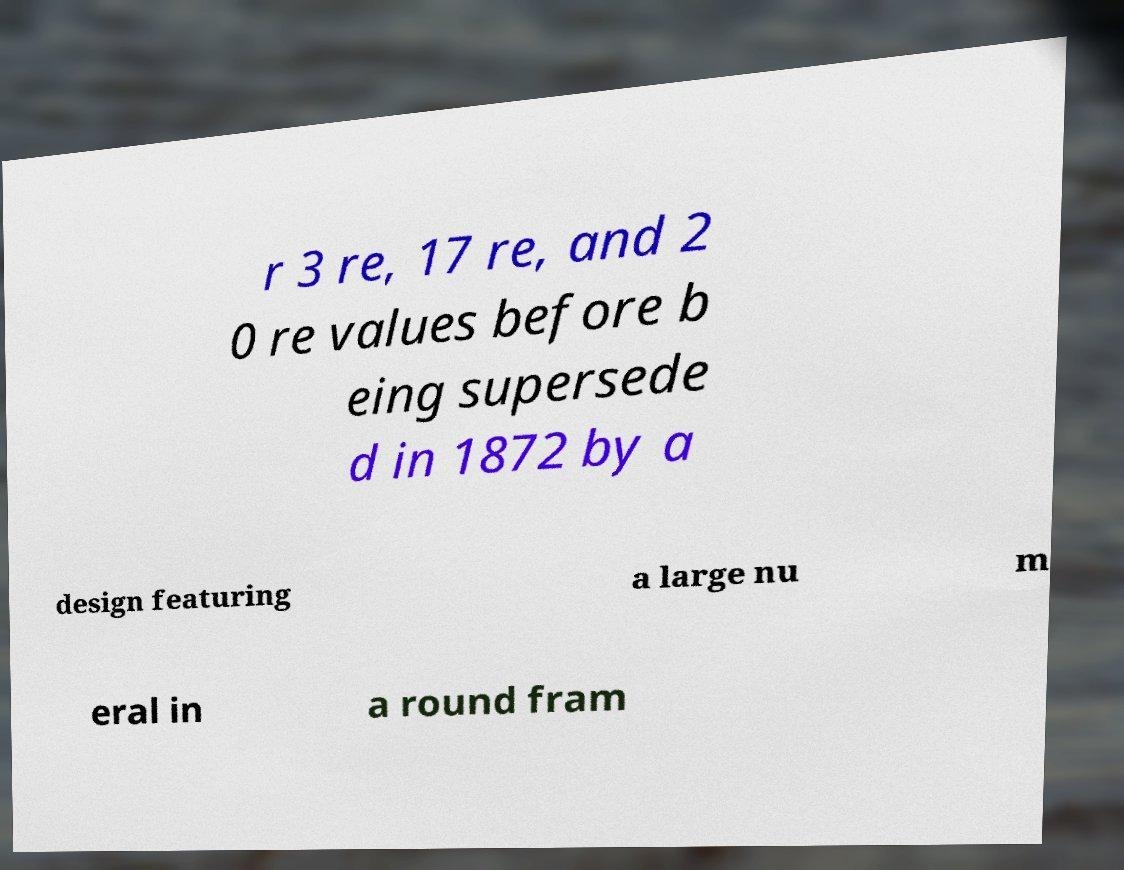Please identify and transcribe the text found in this image. r 3 re, 17 re, and 2 0 re values before b eing supersede d in 1872 by a design featuring a large nu m eral in a round fram 